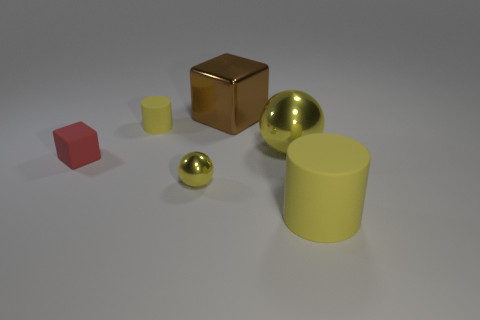Add 2 yellow rubber objects. How many objects exist? 8 Subtract all brown blocks. How many blocks are left? 1 Subtract all cubes. How many objects are left? 4 Subtract 1 blocks. How many blocks are left? 1 Subtract all brown spheres. Subtract all cyan cubes. How many spheres are left? 2 Subtract all cyan cylinders. How many cyan balls are left? 0 Subtract all big metallic objects. Subtract all matte cylinders. How many objects are left? 2 Add 4 big brown metal cubes. How many big brown metal cubes are left? 5 Add 2 big brown matte things. How many big brown matte things exist? 2 Subtract 1 brown blocks. How many objects are left? 5 